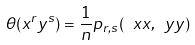Convert formula to latex. <formula><loc_0><loc_0><loc_500><loc_500>\theta ( x ^ { r } y ^ { s } ) = \frac { 1 } { n } p _ { r , s } ( \ x x , \ y y )</formula> 